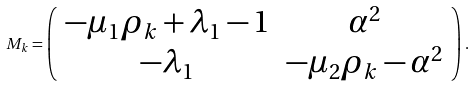<formula> <loc_0><loc_0><loc_500><loc_500>M _ { k } = \left ( \begin{array} { c c } - \mu _ { 1 } \rho _ { k } + \lambda _ { 1 } - 1 & \alpha ^ { 2 } \\ - \lambda _ { 1 } & - \mu _ { 2 } \rho _ { k } - \alpha ^ { 2 } \end{array} \right ) .</formula> 